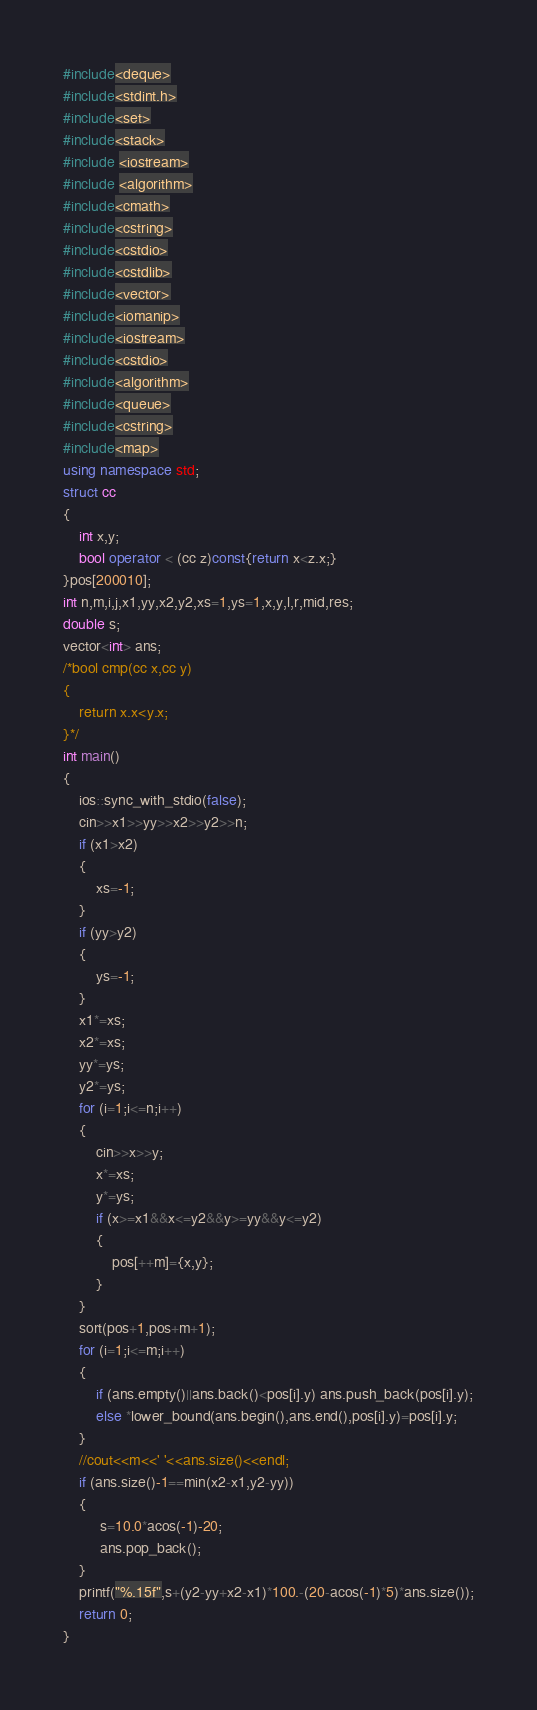<code> <loc_0><loc_0><loc_500><loc_500><_C++_>#include<deque>
#include<stdint.h>
#include<set>
#include<stack>
#include <iostream>
#include <algorithm>
#include<cmath>
#include<cstring>
#include<cstdio>
#include<cstdlib>
#include<vector>
#include<iomanip>
#include<iostream>
#include<cstdio>
#include<algorithm>
#include<queue>
#include<cstring>
#include<map>
using namespace std;
struct cc
{
	int x,y;
	bool operator < (cc z)const{return x<z.x;} 
}pos[200010];
int n,m,i,j,x1,yy,x2,y2,xs=1,ys=1,x,y,l,r,mid,res;
double s; 
vector<int> ans;
/*bool cmp(cc x,cc y)
{
	return x.x<y.x;
}*/
int main()
{
	ios::sync_with_stdio(false);
	cin>>x1>>yy>>x2>>y2>>n;
	if (x1>x2)
	{
		xs=-1;
	}
	if (yy>y2)
	{
		ys=-1;
	}
	x1*=xs;
	x2*=xs;
	yy*=ys;
	y2*=ys;
	for (i=1;i<=n;i++)
	{
		cin>>x>>y;
		x*=xs;
		y*=ys;
		if (x>=x1&&x<=y2&&y>=yy&&y<=y2)
		{
			pos[++m]={x,y};
		}
	}
	sort(pos+1,pos+m+1);
	for (i=1;i<=m;i++)
	{
		if (ans.empty()||ans.back()<pos[i].y) ans.push_back(pos[i].y);
		else *lower_bound(ans.begin(),ans.end(),pos[i].y)=pos[i].y;
	}
	//cout<<m<<' '<<ans.size()<<endl;
	if (ans.size()-1==min(x2-x1,y2-yy))
	{
		 s=10.0*acos(-1)-20;
		 ans.pop_back();
	}
	printf("%.15f",s+(y2-yy+x2-x1)*100.-(20-acos(-1)*5)*ans.size());
	return 0;
}</code> 